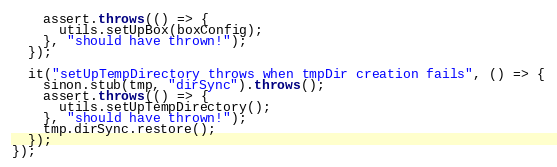Convert code to text. <code><loc_0><loc_0><loc_500><loc_500><_JavaScript_>
    assert.throws(() => {
      utils.setUpBox(boxConfig);
    }, "should have thrown!");
  });

  it("setUpTempDirectory throws when tmpDir creation fails", () => {
    sinon.stub(tmp, "dirSync").throws();
    assert.throws(() => {
      utils.setUpTempDirectory();
    }, "should have thrown!");
    tmp.dirSync.restore();
  });
});
</code> 